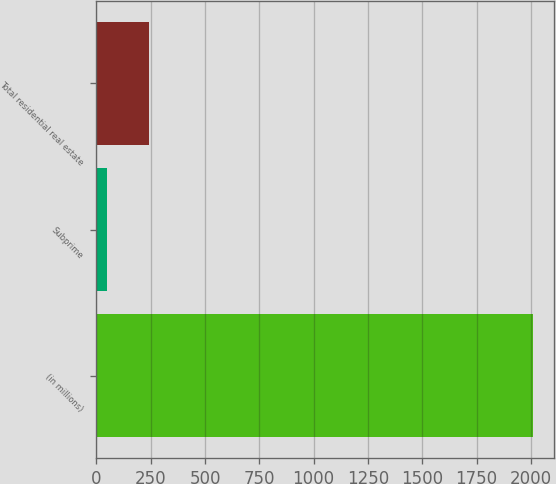<chart> <loc_0><loc_0><loc_500><loc_500><bar_chart><fcel>(in millions)<fcel>Subprime<fcel>Total residential real estate<nl><fcel>2008<fcel>47<fcel>243.1<nl></chart> 